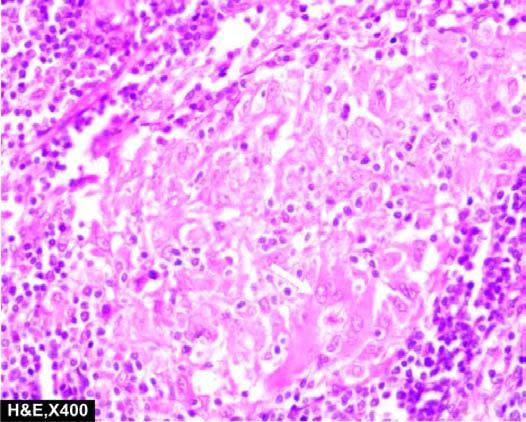re there non-caseating epithelioid cell granulomas which have paucity of lymphocytes?
Answer the question using a single word or phrase. Yes 